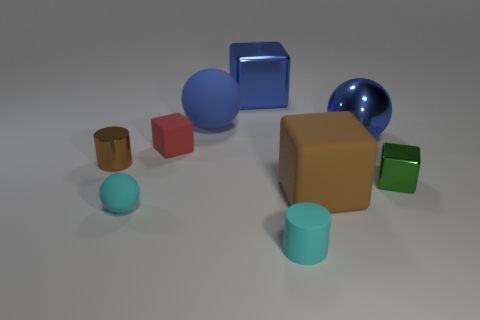There is a cube to the left of the big rubber thing to the left of the cyan matte object in front of the tiny cyan sphere; how big is it?
Offer a terse response. Small. There is a rubber object that is behind the green object and to the right of the tiny red thing; what size is it?
Offer a very short reply. Large. There is a tiny shiny object that is left of the matte cylinder; is it the same color as the large ball that is to the left of the large blue shiny block?
Make the answer very short. No. There is a small metallic block; how many tiny brown objects are to the right of it?
Keep it short and to the point. 0. Is there a metal block to the left of the metal block that is on the left side of the small block in front of the small brown shiny thing?
Make the answer very short. No. How many metal cylinders have the same size as the green shiny cube?
Offer a very short reply. 1. There is a large thing to the left of the metallic thing behind the metallic sphere; what is its material?
Your answer should be very brief. Rubber. What is the shape of the big metal object that is behind the large ball in front of the blue ball that is to the left of the large brown rubber block?
Your answer should be compact. Cube. Is the shape of the tiny rubber object behind the tiny brown metallic cylinder the same as the small shiny thing that is to the right of the small brown cylinder?
Keep it short and to the point. Yes. How many other objects are the same material as the red block?
Ensure brevity in your answer.  4. 